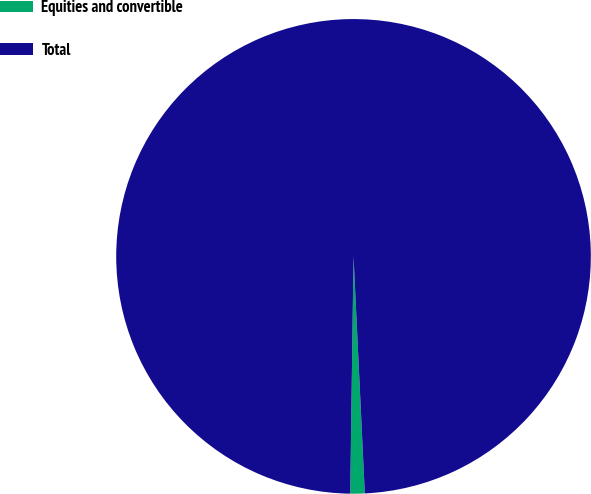<chart> <loc_0><loc_0><loc_500><loc_500><pie_chart><fcel>Equities and convertible<fcel>Total<nl><fcel>0.98%<fcel>99.02%<nl></chart> 